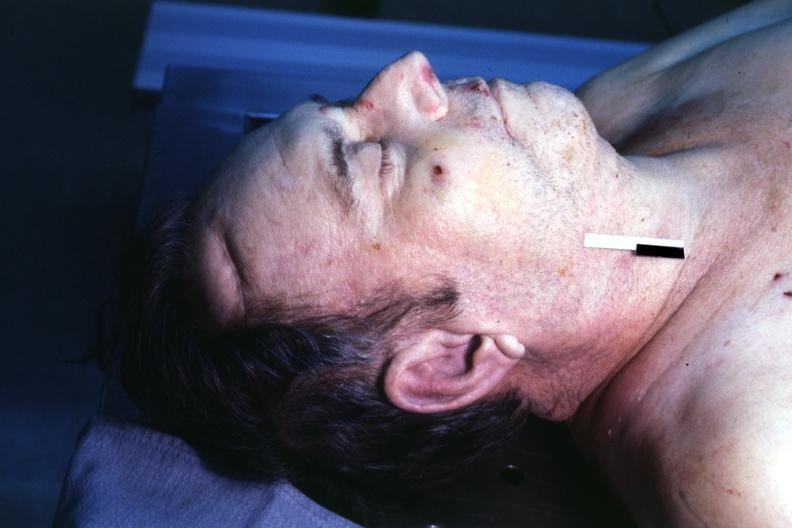does bicornate uterus show body on autopsy table lesion that supposedly predicts premature coronary disease is easily seen?
Answer the question using a single word or phrase. No 